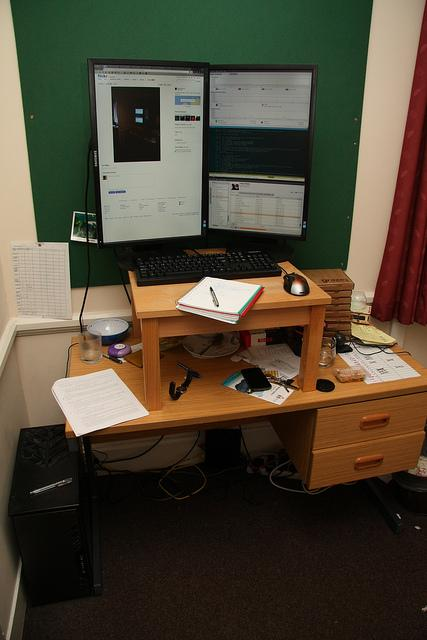Where does the black and silver item in the middle compartment belong?

Choices:
A) ankle
B) neck
C) wrist
D) waist wrist 